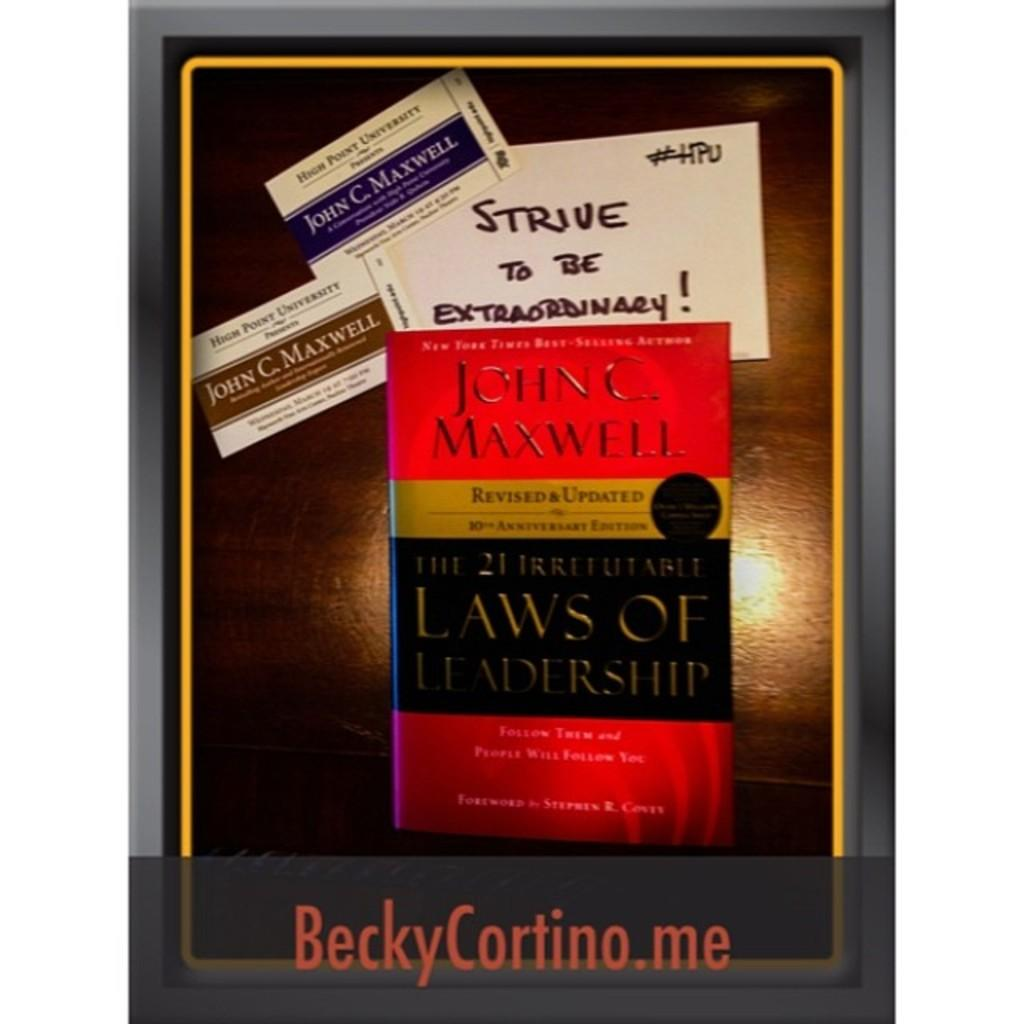<image>
Present a compact description of the photo's key features. a John C. Maxwell book that is with others 